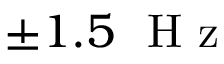<formula> <loc_0><loc_0><loc_500><loc_500>\pm 1 . 5 \ H z</formula> 